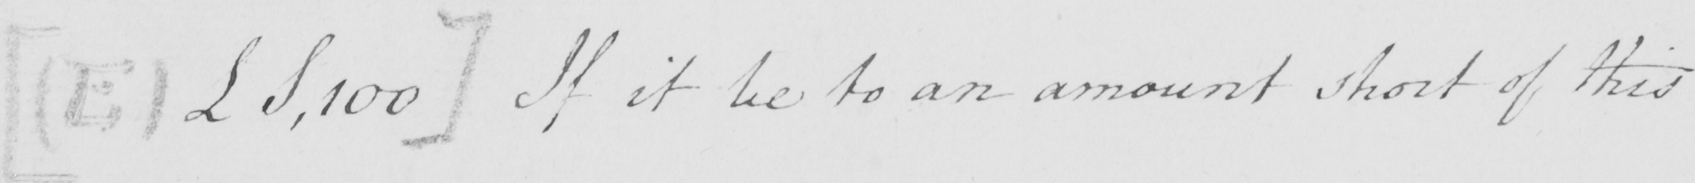What does this handwritten line say? [  ( E )  £S,100 ]  If it be to an amount short of this 